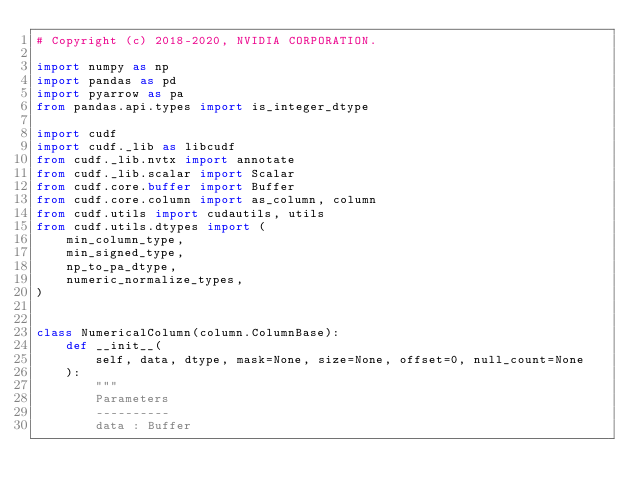Convert code to text. <code><loc_0><loc_0><loc_500><loc_500><_Python_># Copyright (c) 2018-2020, NVIDIA CORPORATION.

import numpy as np
import pandas as pd
import pyarrow as pa
from pandas.api.types import is_integer_dtype

import cudf
import cudf._lib as libcudf
from cudf._lib.nvtx import annotate
from cudf._lib.scalar import Scalar
from cudf.core.buffer import Buffer
from cudf.core.column import as_column, column
from cudf.utils import cudautils, utils
from cudf.utils.dtypes import (
    min_column_type,
    min_signed_type,
    np_to_pa_dtype,
    numeric_normalize_types,
)


class NumericalColumn(column.ColumnBase):
    def __init__(
        self, data, dtype, mask=None, size=None, offset=0, null_count=None
    ):
        """
        Parameters
        ----------
        data : Buffer</code> 